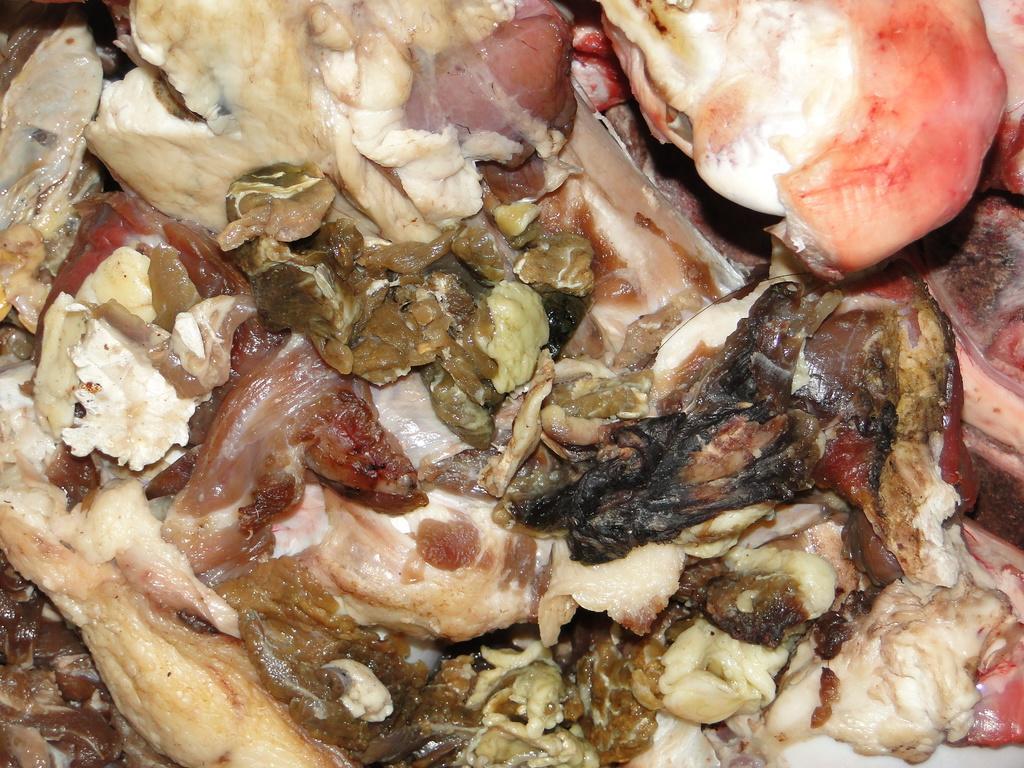Can you describe this image briefly? In this picture we can see meat. 